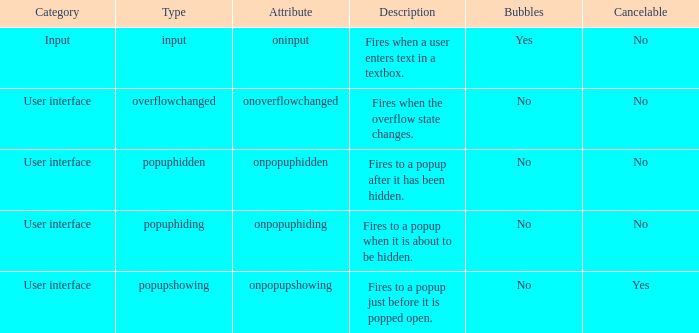 how many bubbles with category being input 1.0. 